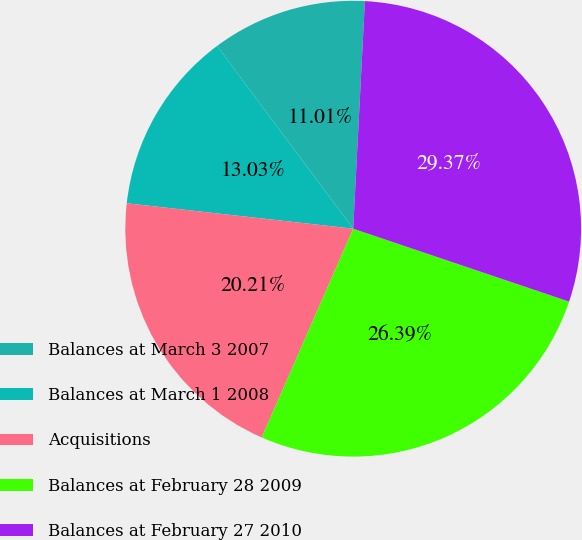Convert chart to OTSL. <chart><loc_0><loc_0><loc_500><loc_500><pie_chart><fcel>Balances at March 3 2007<fcel>Balances at March 1 2008<fcel>Acquisitions<fcel>Balances at February 28 2009<fcel>Balances at February 27 2010<nl><fcel>11.01%<fcel>13.03%<fcel>20.21%<fcel>26.39%<fcel>29.37%<nl></chart> 